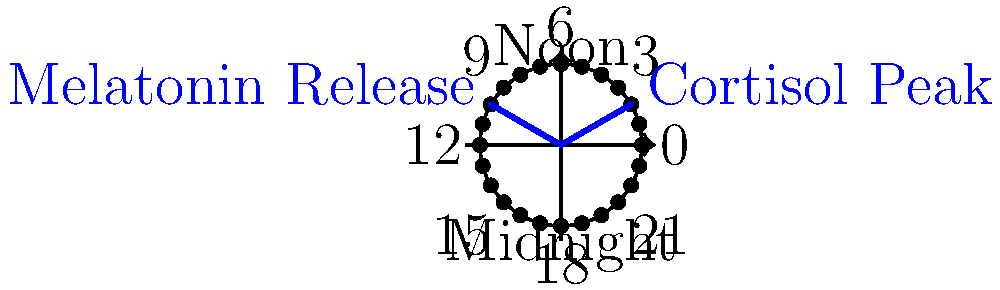In the 24-hour circadian rhythm cycle shown, at what time does melatonin release typically begin, and how many hours after the cortisol peak does this occur? To answer this question, let's follow these steps:

1. Identify the cortisol peak:
   - The blue line pointing to 2:00 is labeled "Cortisol Peak"
   - Cortisol typically peaks early in the morning, around 2:00 AM

2. Identify the melatonin release:
   - The blue line pointing to 10:00 is labeled "Melatonin Release"
   - Melatonin release typically begins in the evening, around 10:00 PM

3. Calculate the time difference:
   - From 2:00 AM to 10:00 PM, we need to count the hours
   - 2:00 AM to 12:00 PM (noon) is 10 hours
   - 12:00 PM to 10:00 PM is another 10 hours
   - Total: 10 + 10 = 20 hours

Therefore, melatonin release typically begins at 10:00 PM, which is 20 hours after the cortisol peak.
Answer: 10:00 PM, 20 hours after cortisol peak 